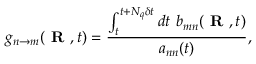<formula> <loc_0><loc_0><loc_500><loc_500>g _ { n \rightarrow m } ( R , t ) = \frac { \int _ { t } ^ { t + N _ { q } \delta t } d t \ b _ { m n } ( R , t ) } { a _ { n n } ( t ) } ,</formula> 